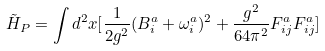Convert formula to latex. <formula><loc_0><loc_0><loc_500><loc_500>\tilde { H } _ { P } = \int d ^ { 2 } x [ \frac { 1 } { 2 g ^ { 2 } } ( B ^ { a } _ { i } + \omega ^ { a } _ { i } ) ^ { 2 } + \frac { g ^ { 2 } } { 6 4 \pi ^ { 2 } } F ^ { a } _ { i j } F ^ { a } _ { i j } ]</formula> 